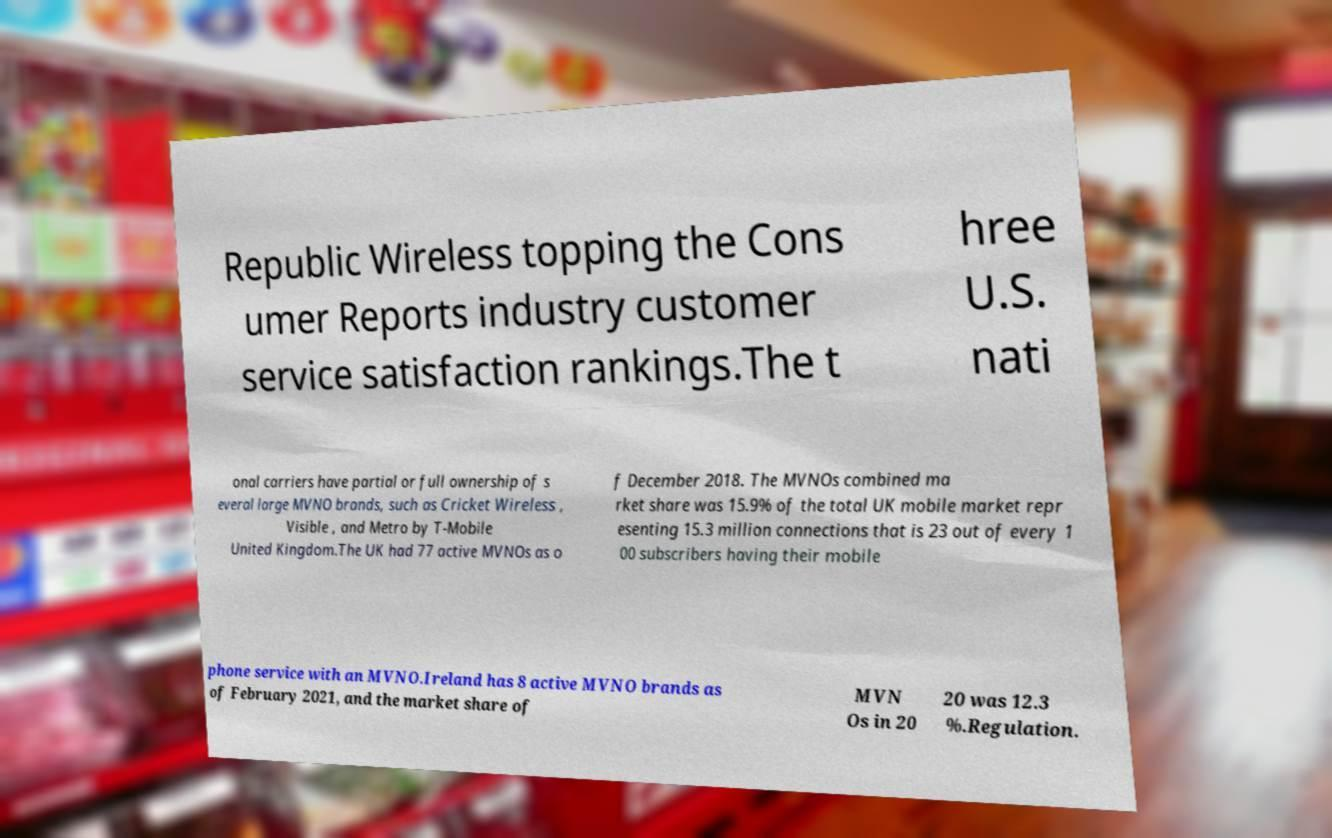I need the written content from this picture converted into text. Can you do that? Republic Wireless topping the Cons umer Reports industry customer service satisfaction rankings.The t hree U.S. nati onal carriers have partial or full ownership of s everal large MVNO brands, such as Cricket Wireless , Visible , and Metro by T-Mobile United Kingdom.The UK had 77 active MVNOs as o f December 2018. The MVNOs combined ma rket share was 15.9% of the total UK mobile market repr esenting 15.3 million connections that is 23 out of every 1 00 subscribers having their mobile phone service with an MVNO.Ireland has 8 active MVNO brands as of February 2021, and the market share of MVN Os in 20 20 was 12.3 %.Regulation. 